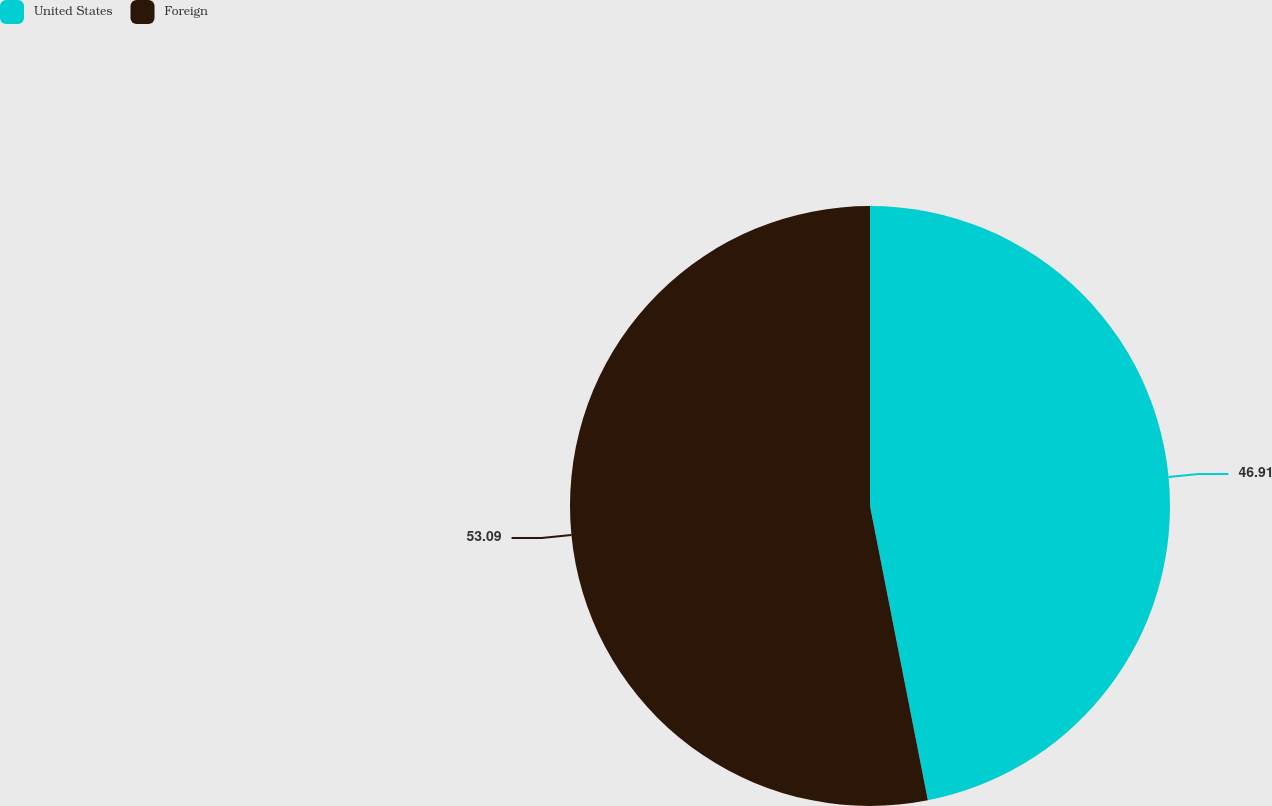<chart> <loc_0><loc_0><loc_500><loc_500><pie_chart><fcel>United States<fcel>Foreign<nl><fcel>46.91%<fcel>53.09%<nl></chart> 